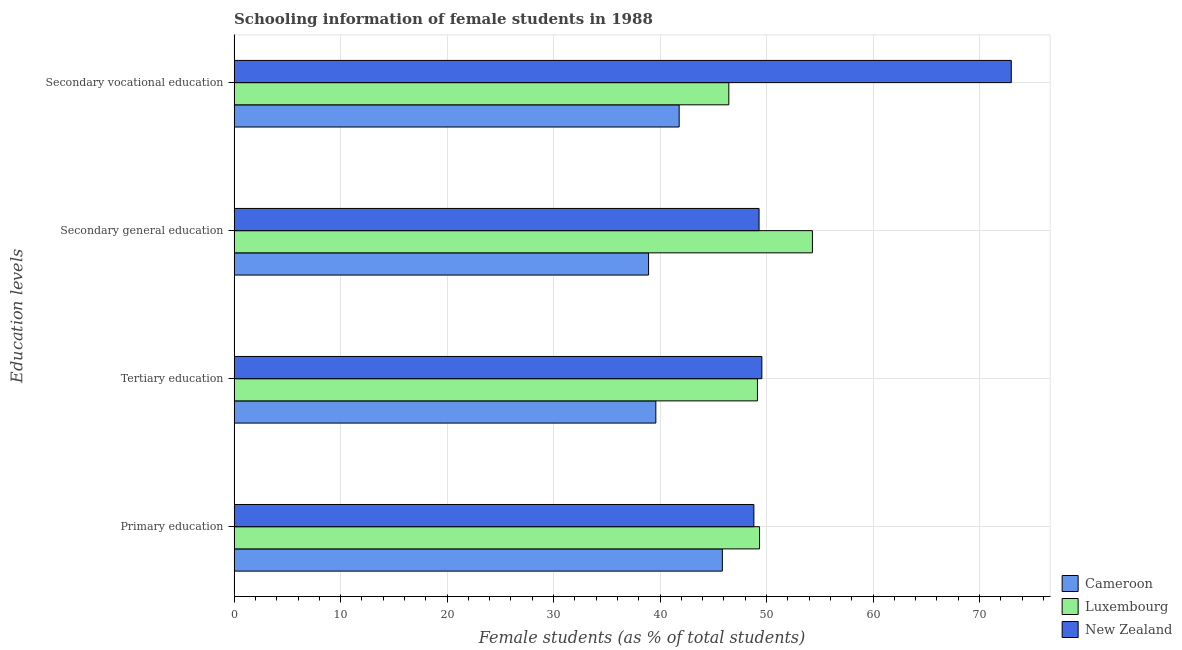How many different coloured bars are there?
Provide a short and direct response. 3. Are the number of bars on each tick of the Y-axis equal?
Make the answer very short. Yes. How many bars are there on the 1st tick from the top?
Your response must be concise. 3. How many bars are there on the 4th tick from the bottom?
Provide a succinct answer. 3. What is the label of the 2nd group of bars from the top?
Offer a very short reply. Secondary general education. What is the percentage of female students in tertiary education in Cameroon?
Provide a short and direct response. 39.6. Across all countries, what is the maximum percentage of female students in primary education?
Ensure brevity in your answer.  49.34. Across all countries, what is the minimum percentage of female students in secondary education?
Your answer should be very brief. 38.92. In which country was the percentage of female students in tertiary education maximum?
Provide a succinct answer. New Zealand. In which country was the percentage of female students in secondary education minimum?
Give a very brief answer. Cameroon. What is the total percentage of female students in primary education in the graph?
Ensure brevity in your answer.  144.01. What is the difference between the percentage of female students in primary education in Luxembourg and that in Cameroon?
Ensure brevity in your answer.  3.49. What is the difference between the percentage of female students in secondary vocational education in Cameroon and the percentage of female students in primary education in Luxembourg?
Give a very brief answer. -7.55. What is the average percentage of female students in secondary vocational education per country?
Your answer should be compact. 53.75. What is the difference between the percentage of female students in secondary vocational education and percentage of female students in primary education in Luxembourg?
Ensure brevity in your answer.  -2.89. In how many countries, is the percentage of female students in primary education greater than 74 %?
Make the answer very short. 0. What is the ratio of the percentage of female students in secondary vocational education in New Zealand to that in Luxembourg?
Offer a very short reply. 1.57. What is the difference between the highest and the second highest percentage of female students in secondary vocational education?
Make the answer very short. 26.53. What is the difference between the highest and the lowest percentage of female students in secondary vocational education?
Your response must be concise. 31.19. Is the sum of the percentage of female students in primary education in Luxembourg and New Zealand greater than the maximum percentage of female students in secondary education across all countries?
Give a very brief answer. Yes. What does the 1st bar from the top in Primary education represents?
Offer a terse response. New Zealand. What does the 2nd bar from the bottom in Primary education represents?
Offer a very short reply. Luxembourg. How many bars are there?
Your answer should be compact. 12. Are all the bars in the graph horizontal?
Offer a very short reply. Yes. How many countries are there in the graph?
Offer a terse response. 3. What is the difference between two consecutive major ticks on the X-axis?
Provide a succinct answer. 10. Does the graph contain any zero values?
Ensure brevity in your answer.  No. Does the graph contain grids?
Offer a very short reply. Yes. Where does the legend appear in the graph?
Ensure brevity in your answer.  Bottom right. What is the title of the graph?
Provide a short and direct response. Schooling information of female students in 1988. What is the label or title of the X-axis?
Ensure brevity in your answer.  Female students (as % of total students). What is the label or title of the Y-axis?
Your answer should be very brief. Education levels. What is the Female students (as % of total students) in Cameroon in Primary education?
Your answer should be very brief. 45.85. What is the Female students (as % of total students) in Luxembourg in Primary education?
Your response must be concise. 49.34. What is the Female students (as % of total students) of New Zealand in Primary education?
Provide a succinct answer. 48.81. What is the Female students (as % of total students) in Cameroon in Tertiary education?
Ensure brevity in your answer.  39.6. What is the Female students (as % of total students) in Luxembourg in Tertiary education?
Your response must be concise. 49.15. What is the Female students (as % of total students) in New Zealand in Tertiary education?
Offer a terse response. 49.56. What is the Female students (as % of total students) in Cameroon in Secondary general education?
Keep it short and to the point. 38.92. What is the Female students (as % of total students) in Luxembourg in Secondary general education?
Make the answer very short. 54.31. What is the Female students (as % of total students) in New Zealand in Secondary general education?
Your answer should be compact. 49.3. What is the Female students (as % of total students) in Cameroon in Secondary vocational education?
Your answer should be compact. 41.79. What is the Female students (as % of total students) of Luxembourg in Secondary vocational education?
Ensure brevity in your answer.  46.46. What is the Female students (as % of total students) in New Zealand in Secondary vocational education?
Offer a terse response. 72.98. Across all Education levels, what is the maximum Female students (as % of total students) in Cameroon?
Make the answer very short. 45.85. Across all Education levels, what is the maximum Female students (as % of total students) in Luxembourg?
Make the answer very short. 54.31. Across all Education levels, what is the maximum Female students (as % of total students) in New Zealand?
Your answer should be very brief. 72.98. Across all Education levels, what is the minimum Female students (as % of total students) in Cameroon?
Make the answer very short. 38.92. Across all Education levels, what is the minimum Female students (as % of total students) in Luxembourg?
Make the answer very short. 46.46. Across all Education levels, what is the minimum Female students (as % of total students) of New Zealand?
Make the answer very short. 48.81. What is the total Female students (as % of total students) of Cameroon in the graph?
Ensure brevity in your answer.  166.17. What is the total Female students (as % of total students) in Luxembourg in the graph?
Your answer should be very brief. 199.26. What is the total Female students (as % of total students) in New Zealand in the graph?
Offer a very short reply. 220.65. What is the difference between the Female students (as % of total students) of Cameroon in Primary education and that in Tertiary education?
Give a very brief answer. 6.25. What is the difference between the Female students (as % of total students) in Luxembourg in Primary education and that in Tertiary education?
Your response must be concise. 0.2. What is the difference between the Female students (as % of total students) in New Zealand in Primary education and that in Tertiary education?
Your answer should be compact. -0.75. What is the difference between the Female students (as % of total students) of Cameroon in Primary education and that in Secondary general education?
Give a very brief answer. 6.93. What is the difference between the Female students (as % of total students) of Luxembourg in Primary education and that in Secondary general education?
Make the answer very short. -4.96. What is the difference between the Female students (as % of total students) of New Zealand in Primary education and that in Secondary general education?
Provide a short and direct response. -0.49. What is the difference between the Female students (as % of total students) in Cameroon in Primary education and that in Secondary vocational education?
Offer a very short reply. 4.06. What is the difference between the Female students (as % of total students) of Luxembourg in Primary education and that in Secondary vocational education?
Offer a terse response. 2.89. What is the difference between the Female students (as % of total students) in New Zealand in Primary education and that in Secondary vocational education?
Your response must be concise. -24.17. What is the difference between the Female students (as % of total students) in Cameroon in Tertiary education and that in Secondary general education?
Ensure brevity in your answer.  0.68. What is the difference between the Female students (as % of total students) in Luxembourg in Tertiary education and that in Secondary general education?
Your answer should be very brief. -5.16. What is the difference between the Female students (as % of total students) in New Zealand in Tertiary education and that in Secondary general education?
Your answer should be compact. 0.26. What is the difference between the Female students (as % of total students) of Cameroon in Tertiary education and that in Secondary vocational education?
Offer a very short reply. -2.19. What is the difference between the Female students (as % of total students) of Luxembourg in Tertiary education and that in Secondary vocational education?
Offer a terse response. 2.69. What is the difference between the Female students (as % of total students) of New Zealand in Tertiary education and that in Secondary vocational education?
Make the answer very short. -23.42. What is the difference between the Female students (as % of total students) of Cameroon in Secondary general education and that in Secondary vocational education?
Your answer should be very brief. -2.87. What is the difference between the Female students (as % of total students) of Luxembourg in Secondary general education and that in Secondary vocational education?
Offer a very short reply. 7.85. What is the difference between the Female students (as % of total students) in New Zealand in Secondary general education and that in Secondary vocational education?
Make the answer very short. -23.69. What is the difference between the Female students (as % of total students) in Cameroon in Primary education and the Female students (as % of total students) in Luxembourg in Tertiary education?
Offer a terse response. -3.3. What is the difference between the Female students (as % of total students) in Cameroon in Primary education and the Female students (as % of total students) in New Zealand in Tertiary education?
Offer a very short reply. -3.71. What is the difference between the Female students (as % of total students) in Luxembourg in Primary education and the Female students (as % of total students) in New Zealand in Tertiary education?
Make the answer very short. -0.22. What is the difference between the Female students (as % of total students) of Cameroon in Primary education and the Female students (as % of total students) of Luxembourg in Secondary general education?
Provide a short and direct response. -8.46. What is the difference between the Female students (as % of total students) in Cameroon in Primary education and the Female students (as % of total students) in New Zealand in Secondary general education?
Your answer should be compact. -3.45. What is the difference between the Female students (as % of total students) in Luxembourg in Primary education and the Female students (as % of total students) in New Zealand in Secondary general education?
Provide a succinct answer. 0.05. What is the difference between the Female students (as % of total students) of Cameroon in Primary education and the Female students (as % of total students) of Luxembourg in Secondary vocational education?
Your answer should be very brief. -0.61. What is the difference between the Female students (as % of total students) of Cameroon in Primary education and the Female students (as % of total students) of New Zealand in Secondary vocational education?
Ensure brevity in your answer.  -27.13. What is the difference between the Female students (as % of total students) in Luxembourg in Primary education and the Female students (as % of total students) in New Zealand in Secondary vocational education?
Make the answer very short. -23.64. What is the difference between the Female students (as % of total students) of Cameroon in Tertiary education and the Female students (as % of total students) of Luxembourg in Secondary general education?
Offer a terse response. -14.7. What is the difference between the Female students (as % of total students) in Cameroon in Tertiary education and the Female students (as % of total students) in New Zealand in Secondary general education?
Offer a terse response. -9.69. What is the difference between the Female students (as % of total students) in Luxembourg in Tertiary education and the Female students (as % of total students) in New Zealand in Secondary general education?
Make the answer very short. -0.15. What is the difference between the Female students (as % of total students) in Cameroon in Tertiary education and the Female students (as % of total students) in Luxembourg in Secondary vocational education?
Ensure brevity in your answer.  -6.85. What is the difference between the Female students (as % of total students) of Cameroon in Tertiary education and the Female students (as % of total students) of New Zealand in Secondary vocational education?
Offer a terse response. -33.38. What is the difference between the Female students (as % of total students) of Luxembourg in Tertiary education and the Female students (as % of total students) of New Zealand in Secondary vocational education?
Give a very brief answer. -23.84. What is the difference between the Female students (as % of total students) in Cameroon in Secondary general education and the Female students (as % of total students) in Luxembourg in Secondary vocational education?
Keep it short and to the point. -7.54. What is the difference between the Female students (as % of total students) in Cameroon in Secondary general education and the Female students (as % of total students) in New Zealand in Secondary vocational education?
Your answer should be very brief. -34.06. What is the difference between the Female students (as % of total students) of Luxembourg in Secondary general education and the Female students (as % of total students) of New Zealand in Secondary vocational education?
Provide a succinct answer. -18.68. What is the average Female students (as % of total students) of Cameroon per Education levels?
Make the answer very short. 41.54. What is the average Female students (as % of total students) in Luxembourg per Education levels?
Give a very brief answer. 49.81. What is the average Female students (as % of total students) of New Zealand per Education levels?
Offer a terse response. 55.16. What is the difference between the Female students (as % of total students) of Cameroon and Female students (as % of total students) of Luxembourg in Primary education?
Your answer should be very brief. -3.49. What is the difference between the Female students (as % of total students) of Cameroon and Female students (as % of total students) of New Zealand in Primary education?
Provide a succinct answer. -2.96. What is the difference between the Female students (as % of total students) in Luxembourg and Female students (as % of total students) in New Zealand in Primary education?
Provide a succinct answer. 0.53. What is the difference between the Female students (as % of total students) of Cameroon and Female students (as % of total students) of Luxembourg in Tertiary education?
Your response must be concise. -9.54. What is the difference between the Female students (as % of total students) in Cameroon and Female students (as % of total students) in New Zealand in Tertiary education?
Your answer should be compact. -9.96. What is the difference between the Female students (as % of total students) of Luxembourg and Female students (as % of total students) of New Zealand in Tertiary education?
Offer a terse response. -0.41. What is the difference between the Female students (as % of total students) in Cameroon and Female students (as % of total students) in Luxembourg in Secondary general education?
Ensure brevity in your answer.  -15.39. What is the difference between the Female students (as % of total students) in Cameroon and Female students (as % of total students) in New Zealand in Secondary general education?
Provide a succinct answer. -10.38. What is the difference between the Female students (as % of total students) in Luxembourg and Female students (as % of total students) in New Zealand in Secondary general education?
Provide a short and direct response. 5.01. What is the difference between the Female students (as % of total students) of Cameroon and Female students (as % of total students) of Luxembourg in Secondary vocational education?
Your answer should be compact. -4.66. What is the difference between the Female students (as % of total students) of Cameroon and Female students (as % of total students) of New Zealand in Secondary vocational education?
Keep it short and to the point. -31.19. What is the difference between the Female students (as % of total students) in Luxembourg and Female students (as % of total students) in New Zealand in Secondary vocational education?
Ensure brevity in your answer.  -26.53. What is the ratio of the Female students (as % of total students) in Cameroon in Primary education to that in Tertiary education?
Provide a short and direct response. 1.16. What is the ratio of the Female students (as % of total students) in New Zealand in Primary education to that in Tertiary education?
Ensure brevity in your answer.  0.98. What is the ratio of the Female students (as % of total students) of Cameroon in Primary education to that in Secondary general education?
Provide a short and direct response. 1.18. What is the ratio of the Female students (as % of total students) in Luxembourg in Primary education to that in Secondary general education?
Your response must be concise. 0.91. What is the ratio of the Female students (as % of total students) in Cameroon in Primary education to that in Secondary vocational education?
Make the answer very short. 1.1. What is the ratio of the Female students (as % of total students) of Luxembourg in Primary education to that in Secondary vocational education?
Ensure brevity in your answer.  1.06. What is the ratio of the Female students (as % of total students) of New Zealand in Primary education to that in Secondary vocational education?
Ensure brevity in your answer.  0.67. What is the ratio of the Female students (as % of total students) in Cameroon in Tertiary education to that in Secondary general education?
Keep it short and to the point. 1.02. What is the ratio of the Female students (as % of total students) of Luxembourg in Tertiary education to that in Secondary general education?
Ensure brevity in your answer.  0.91. What is the ratio of the Female students (as % of total students) in New Zealand in Tertiary education to that in Secondary general education?
Make the answer very short. 1.01. What is the ratio of the Female students (as % of total students) of Cameroon in Tertiary education to that in Secondary vocational education?
Provide a short and direct response. 0.95. What is the ratio of the Female students (as % of total students) in Luxembourg in Tertiary education to that in Secondary vocational education?
Ensure brevity in your answer.  1.06. What is the ratio of the Female students (as % of total students) in New Zealand in Tertiary education to that in Secondary vocational education?
Make the answer very short. 0.68. What is the ratio of the Female students (as % of total students) of Cameroon in Secondary general education to that in Secondary vocational education?
Your answer should be very brief. 0.93. What is the ratio of the Female students (as % of total students) of Luxembourg in Secondary general education to that in Secondary vocational education?
Ensure brevity in your answer.  1.17. What is the ratio of the Female students (as % of total students) in New Zealand in Secondary general education to that in Secondary vocational education?
Offer a very short reply. 0.68. What is the difference between the highest and the second highest Female students (as % of total students) of Cameroon?
Your answer should be compact. 4.06. What is the difference between the highest and the second highest Female students (as % of total students) of Luxembourg?
Offer a terse response. 4.96. What is the difference between the highest and the second highest Female students (as % of total students) of New Zealand?
Your answer should be compact. 23.42. What is the difference between the highest and the lowest Female students (as % of total students) in Cameroon?
Make the answer very short. 6.93. What is the difference between the highest and the lowest Female students (as % of total students) in Luxembourg?
Give a very brief answer. 7.85. What is the difference between the highest and the lowest Female students (as % of total students) in New Zealand?
Keep it short and to the point. 24.17. 